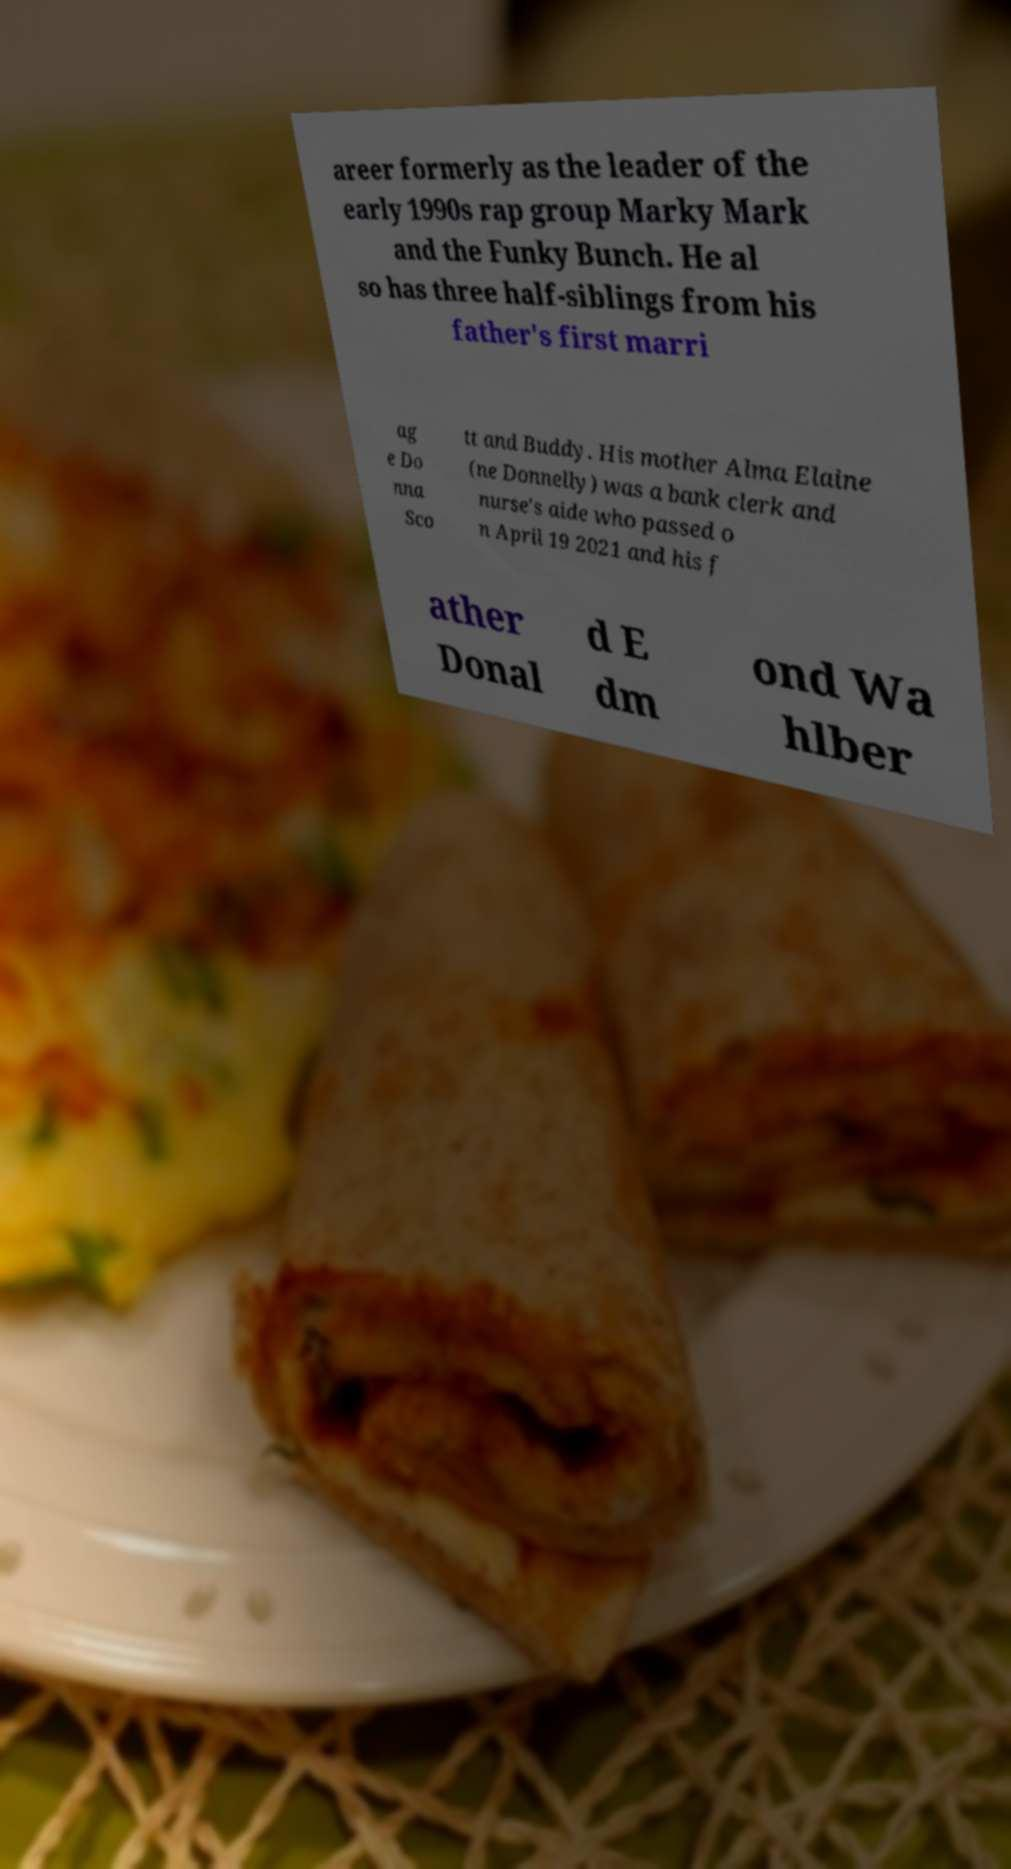I need the written content from this picture converted into text. Can you do that? areer formerly as the leader of the early 1990s rap group Marky Mark and the Funky Bunch. He al so has three half-siblings from his father's first marri ag e Do nna Sco tt and Buddy. His mother Alma Elaine (ne Donnelly) was a bank clerk and nurse's aide who passed o n April 19 2021 and his f ather Donal d E dm ond Wa hlber 